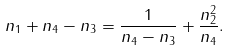Convert formula to latex. <formula><loc_0><loc_0><loc_500><loc_500>n _ { 1 } + n _ { 4 } - n _ { 3 } = \frac { 1 } { n _ { 4 } - n _ { 3 } } + \frac { n _ { 2 } ^ { 2 } } { n _ { 4 } } .</formula> 